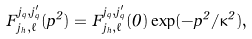<formula> <loc_0><loc_0><loc_500><loc_500>F _ { j _ { h } , \ell } ^ { j _ { q } , j _ { q } ^ { \prime } } ( p ^ { 2 } ) = F _ { j _ { h } , \ell } ^ { j _ { q } , j _ { q } ^ { \prime } } ( 0 ) \exp ( - p ^ { 2 } / \kappa ^ { 2 } ) ,</formula> 